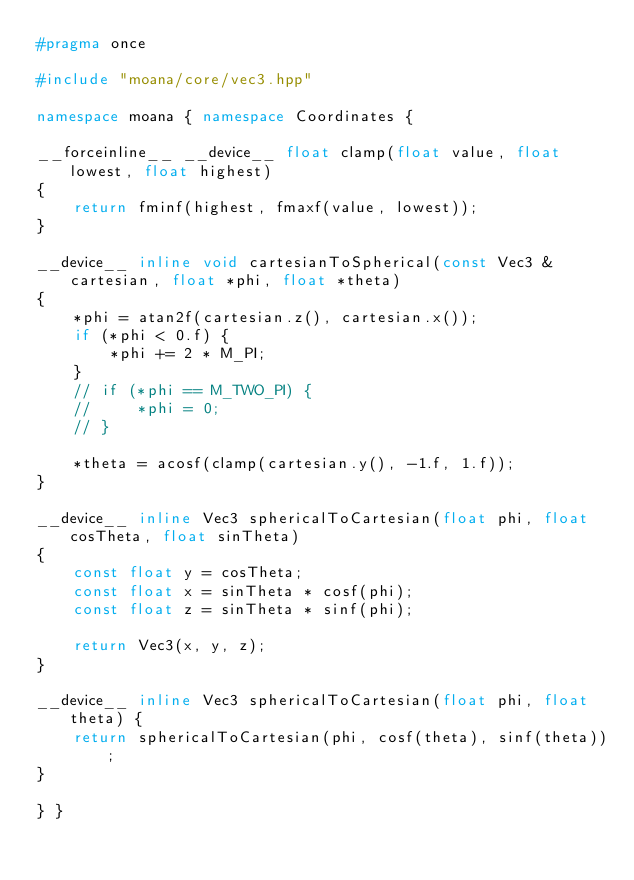<code> <loc_0><loc_0><loc_500><loc_500><_C++_>#pragma once

#include "moana/core/vec3.hpp"

namespace moana { namespace Coordinates {

__forceinline__ __device__ float clamp(float value, float lowest, float highest)
{
    return fminf(highest, fmaxf(value, lowest));
}

__device__ inline void cartesianToSpherical(const Vec3 &cartesian, float *phi, float *theta)
{
    *phi = atan2f(cartesian.z(), cartesian.x());
    if (*phi < 0.f) {
        *phi += 2 * M_PI;
    }
    // if (*phi == M_TWO_PI) {
    //     *phi = 0;
    // }

    *theta = acosf(clamp(cartesian.y(), -1.f, 1.f));
}

__device__ inline Vec3 sphericalToCartesian(float phi, float cosTheta, float sinTheta)
{
    const float y = cosTheta;
    const float x = sinTheta * cosf(phi);
    const float z = sinTheta * sinf(phi);

    return Vec3(x, y, z);
}

__device__ inline Vec3 sphericalToCartesian(float phi, float theta) {
    return sphericalToCartesian(phi, cosf(theta), sinf(theta));
}

} }
</code> 